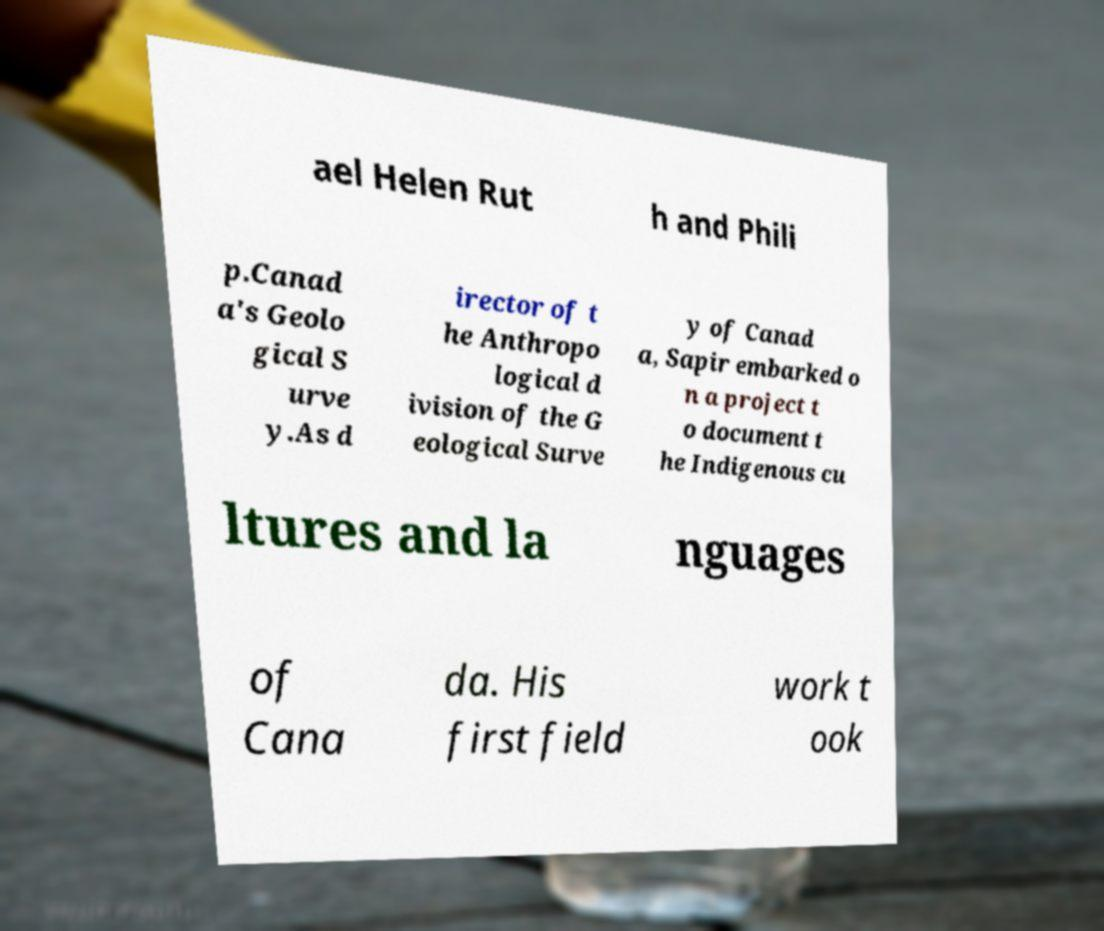For documentation purposes, I need the text within this image transcribed. Could you provide that? ael Helen Rut h and Phili p.Canad a's Geolo gical S urve y.As d irector of t he Anthropo logical d ivision of the G eological Surve y of Canad a, Sapir embarked o n a project t o document t he Indigenous cu ltures and la nguages of Cana da. His first field work t ook 